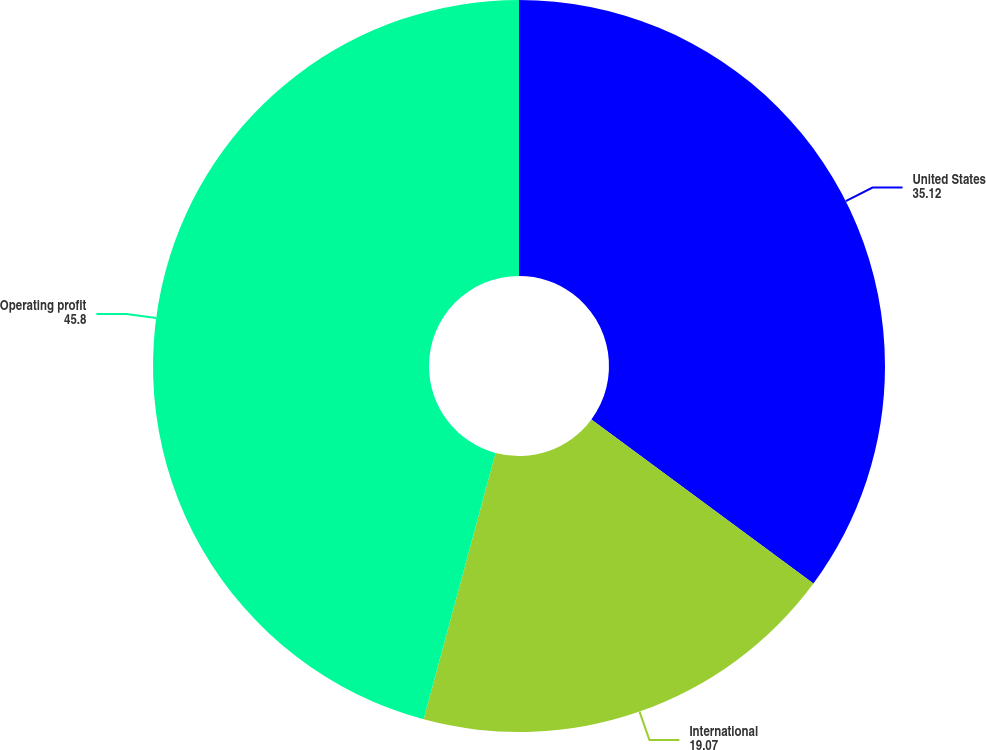Convert chart. <chart><loc_0><loc_0><loc_500><loc_500><pie_chart><fcel>United States<fcel>International<fcel>Operating profit<nl><fcel>35.12%<fcel>19.07%<fcel>45.8%<nl></chart> 